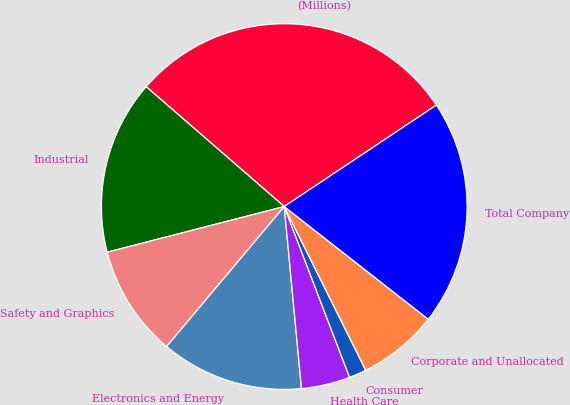<chart> <loc_0><loc_0><loc_500><loc_500><pie_chart><fcel>(Millions)<fcel>Industrial<fcel>Safety and Graphics<fcel>Electronics and Energy<fcel>Health Care<fcel>Consumer<fcel>Corporate and Unallocated<fcel>Total Company<nl><fcel>29.26%<fcel>15.4%<fcel>9.86%<fcel>12.63%<fcel>4.31%<fcel>1.54%<fcel>7.08%<fcel>19.93%<nl></chart> 